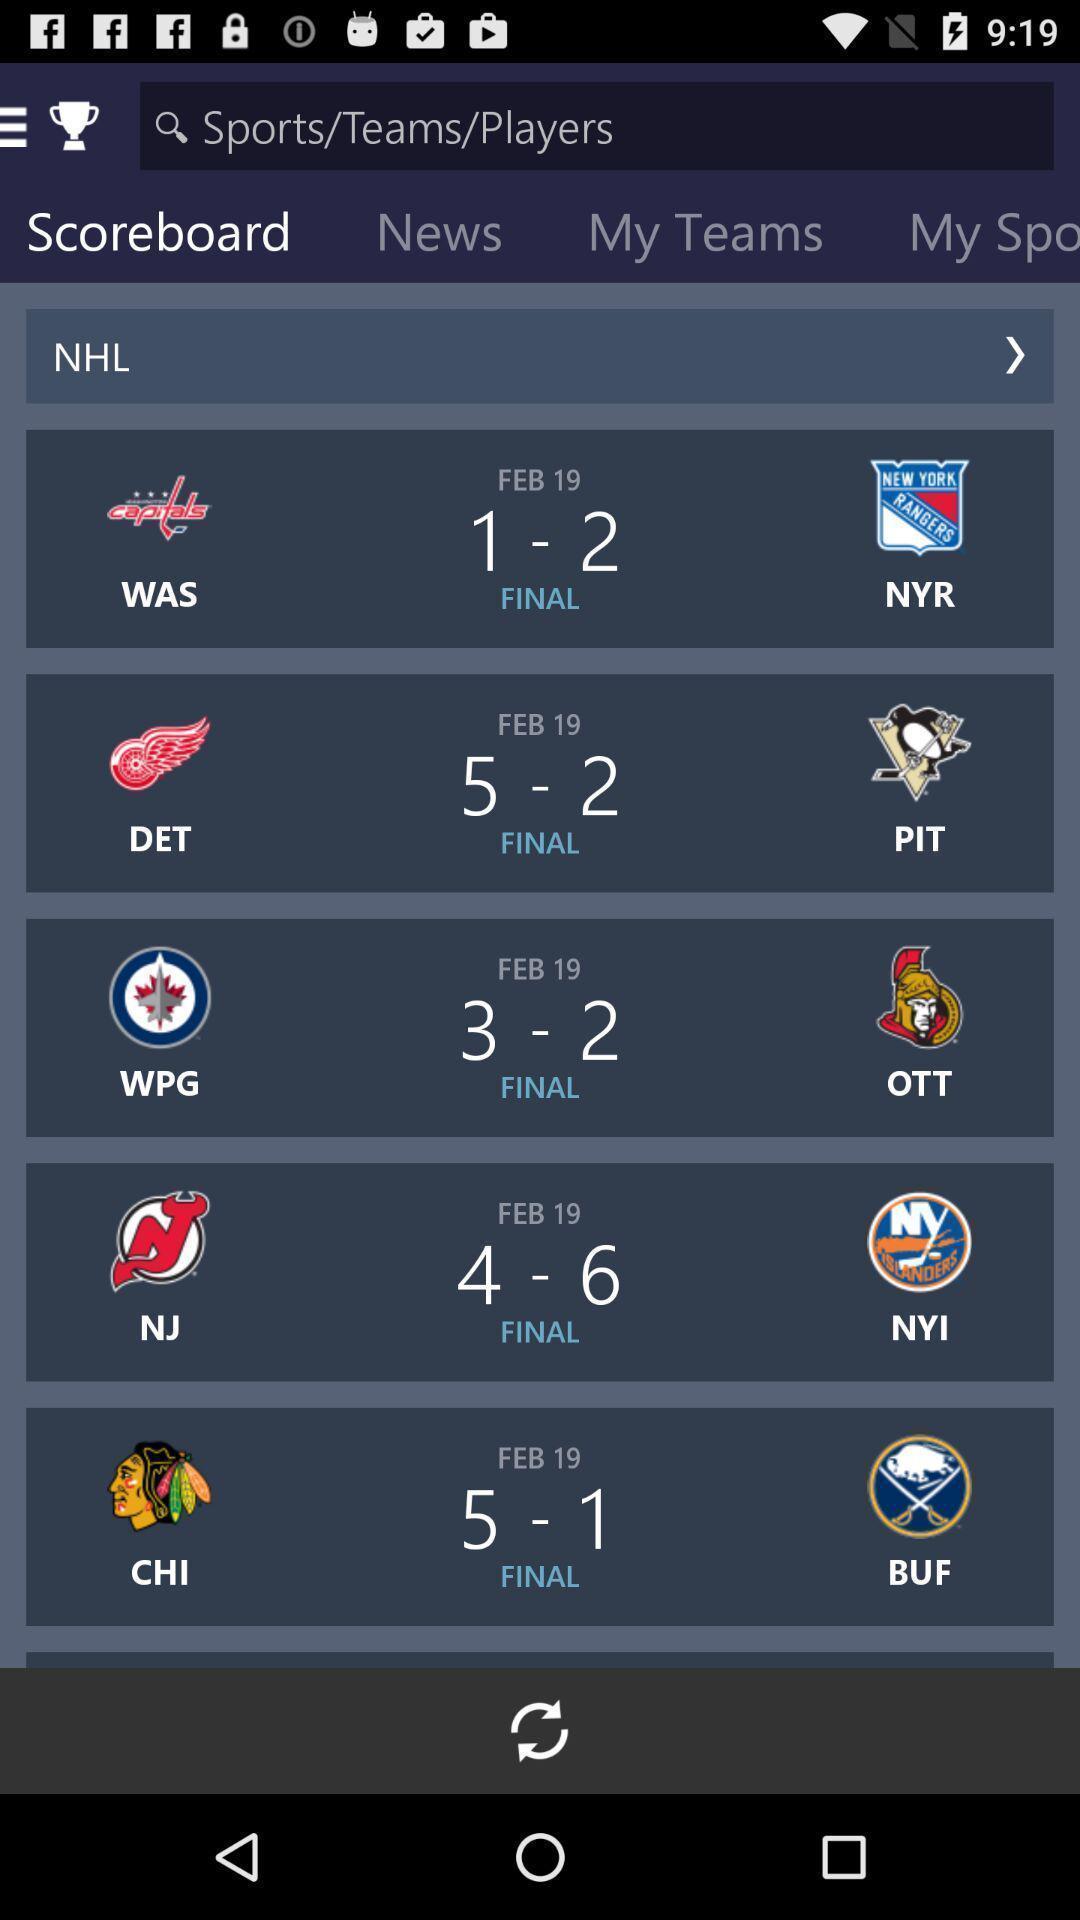What can you discern from this picture? Screen showing scoreboard in an sports applications. 